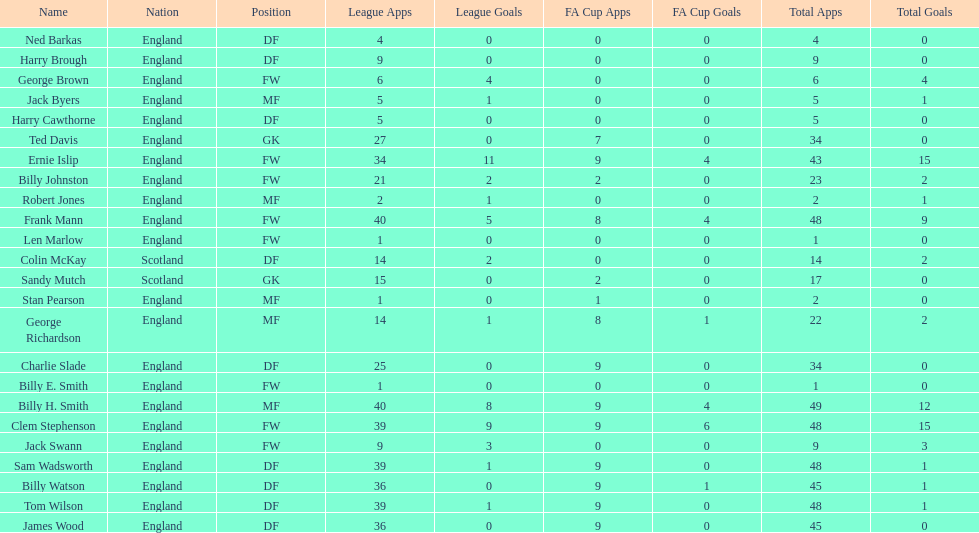Mean count of goals netted by athletes from scotland 1. Could you parse the entire table as a dict? {'header': ['Name', 'Nation', 'Position', 'League Apps', 'League Goals', 'FA Cup Apps', 'FA Cup Goals', 'Total Apps', 'Total Goals'], 'rows': [['Ned Barkas', 'England', 'DF', '4', '0', '0', '0', '4', '0'], ['Harry Brough', 'England', 'DF', '9', '0', '0', '0', '9', '0'], ['George Brown', 'England', 'FW', '6', '4', '0', '0', '6', '4'], ['Jack Byers', 'England', 'MF', '5', '1', '0', '0', '5', '1'], ['Harry Cawthorne', 'England', 'DF', '5', '0', '0', '0', '5', '0'], ['Ted Davis', 'England', 'GK', '27', '0', '7', '0', '34', '0'], ['Ernie Islip', 'England', 'FW', '34', '11', '9', '4', '43', '15'], ['Billy Johnston', 'England', 'FW', '21', '2', '2', '0', '23', '2'], ['Robert Jones', 'England', 'MF', '2', '1', '0', '0', '2', '1'], ['Frank Mann', 'England', 'FW', '40', '5', '8', '4', '48', '9'], ['Len Marlow', 'England', 'FW', '1', '0', '0', '0', '1', '0'], ['Colin McKay', 'Scotland', 'DF', '14', '2', '0', '0', '14', '2'], ['Sandy Mutch', 'Scotland', 'GK', '15', '0', '2', '0', '17', '0'], ['Stan Pearson', 'England', 'MF', '1', '0', '1', '0', '2', '0'], ['George Richardson', 'England', 'MF', '14', '1', '8', '1', '22', '2'], ['Charlie Slade', 'England', 'DF', '25', '0', '9', '0', '34', '0'], ['Billy E. Smith', 'England', 'FW', '1', '0', '0', '0', '1', '0'], ['Billy H. Smith', 'England', 'MF', '40', '8', '9', '4', '49', '12'], ['Clem Stephenson', 'England', 'FW', '39', '9', '9', '6', '48', '15'], ['Jack Swann', 'England', 'FW', '9', '3', '0', '0', '9', '3'], ['Sam Wadsworth', 'England', 'DF', '39', '1', '9', '0', '48', '1'], ['Billy Watson', 'England', 'DF', '36', '0', '9', '1', '45', '1'], ['Tom Wilson', 'England', 'DF', '39', '1', '9', '0', '48', '1'], ['James Wood', 'England', 'DF', '36', '0', '9', '0', '45', '0']]} 